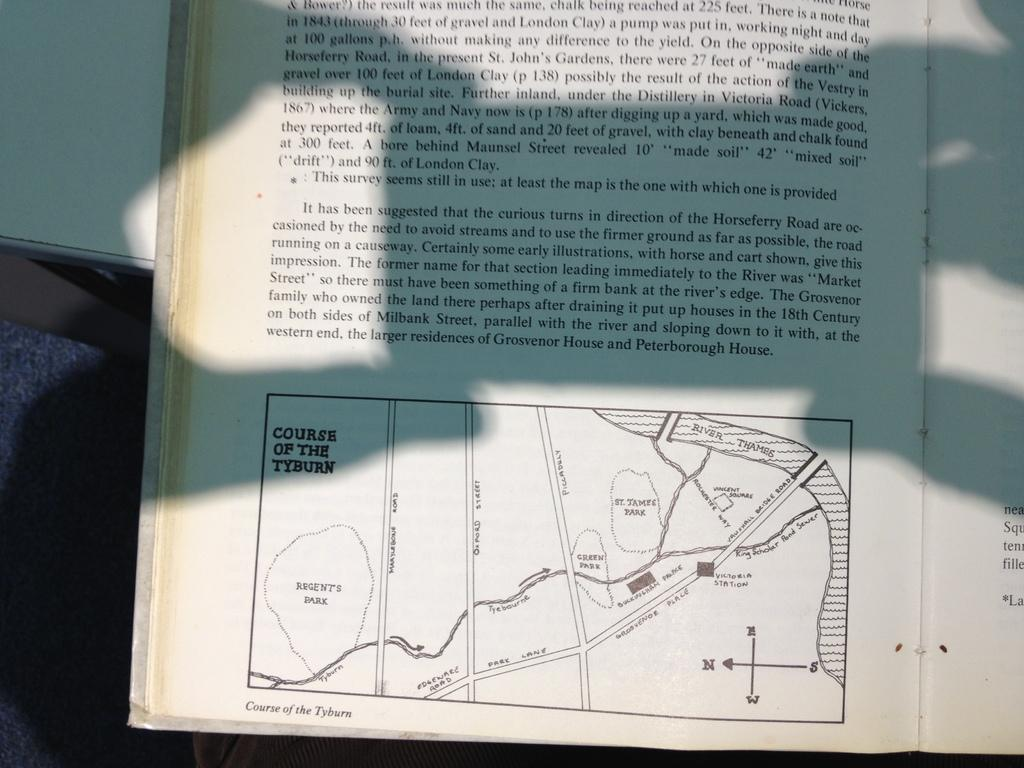<image>
Present a compact description of the photo's key features. A page from a book shows a map of the course of the Tyburn River through London. 